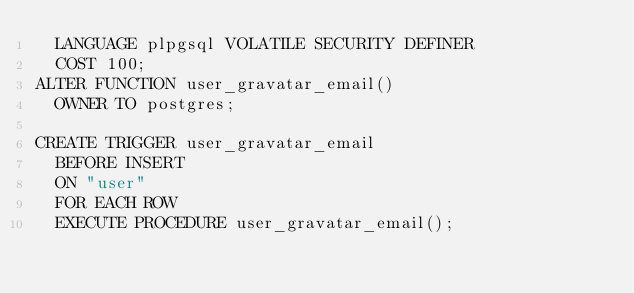<code> <loc_0><loc_0><loc_500><loc_500><_SQL_>  LANGUAGE plpgsql VOLATILE SECURITY DEFINER
  COST 100;
ALTER FUNCTION user_gravatar_email()
  OWNER TO postgres;

CREATE TRIGGER user_gravatar_email
  BEFORE INSERT
  ON "user"
  FOR EACH ROW
  EXECUTE PROCEDURE user_gravatar_email();
</code> 